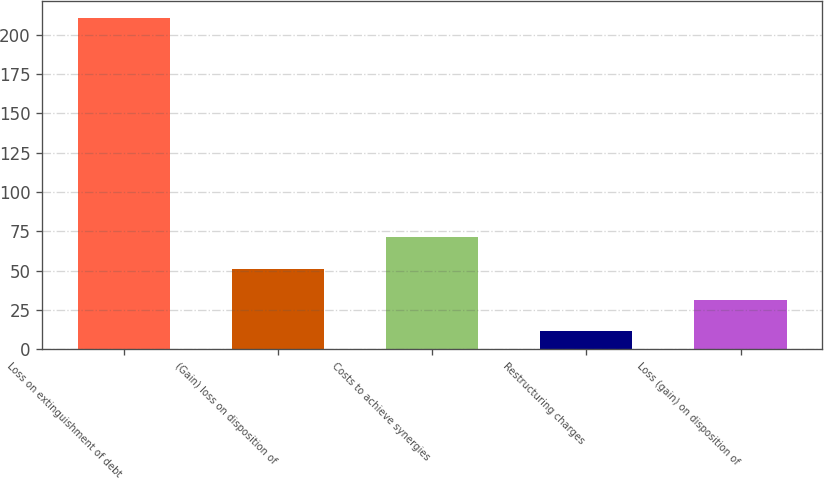<chart> <loc_0><loc_0><loc_500><loc_500><bar_chart><fcel>Loss on extinguishment of debt<fcel>(Gain) loss on disposition of<fcel>Costs to achieve synergies<fcel>Restructuring charges<fcel>Loss (gain) on disposition of<nl><fcel>210.8<fcel>51.28<fcel>71.22<fcel>11.4<fcel>31.34<nl></chart> 